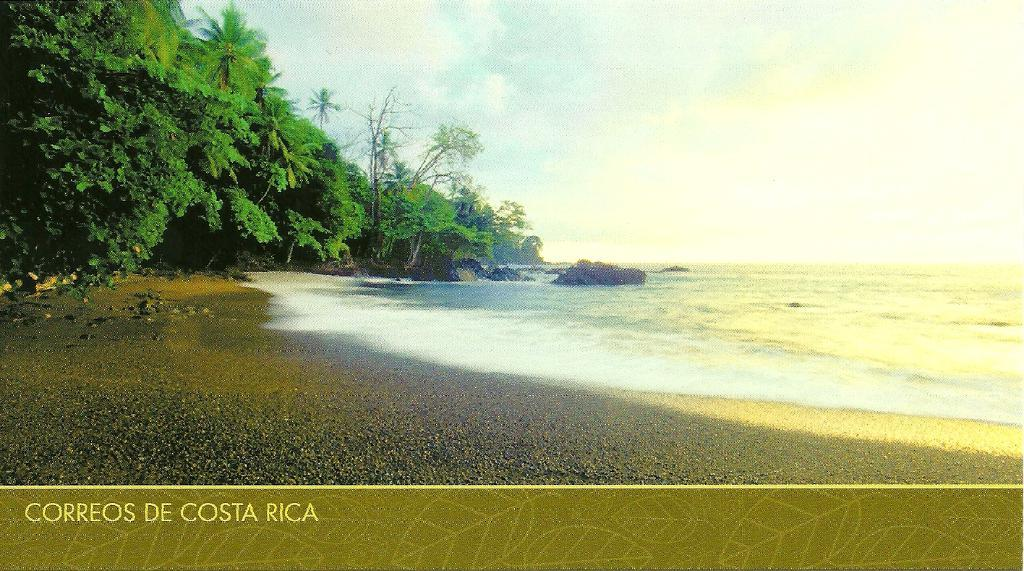What type of terrain is visible in the image? There is ground visible in the image. What type of vegetation can be seen in the image? There are green trees in the image. What other large objects are present in the image? There are huge rocks in the image. What else can be seen in the image besides the ground, trees, and rocks? There is water visible in the image. What is visible in the background of the image? The sky is visible in the background of the image. Can you tell me how many berries are growing on the trees in the image? There are no berries visible in the image; the trees are green but do not have any berries. What type of lace can be seen on the rocks in the image? There is no lace present in the image; the rocks are large and natural. 